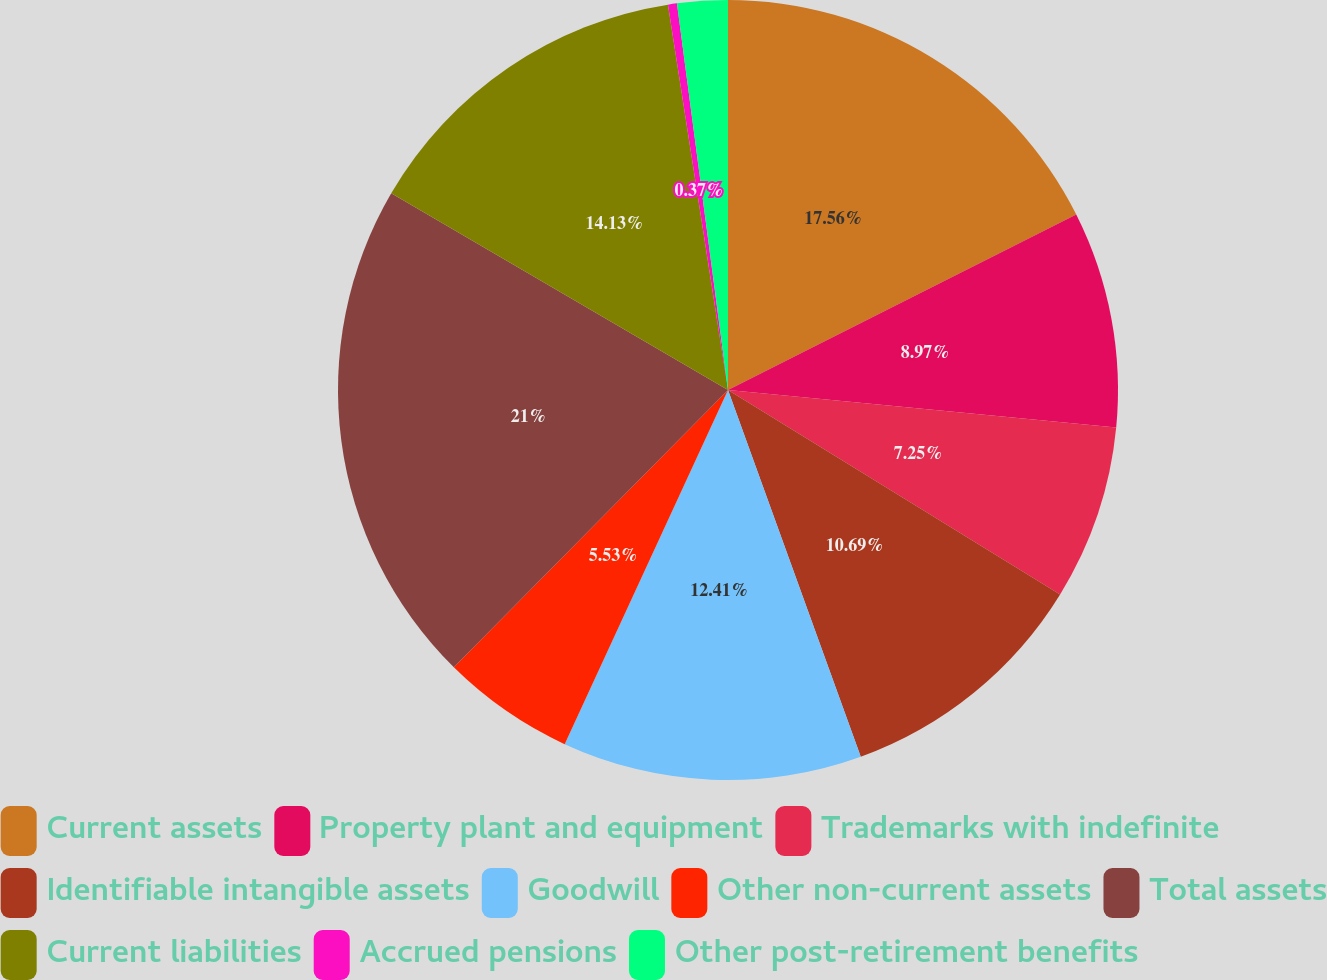<chart> <loc_0><loc_0><loc_500><loc_500><pie_chart><fcel>Current assets<fcel>Property plant and equipment<fcel>Trademarks with indefinite<fcel>Identifiable intangible assets<fcel>Goodwill<fcel>Other non-current assets<fcel>Total assets<fcel>Current liabilities<fcel>Accrued pensions<fcel>Other post-retirement benefits<nl><fcel>17.57%<fcel>8.97%<fcel>7.25%<fcel>10.69%<fcel>12.41%<fcel>5.53%<fcel>21.01%<fcel>14.13%<fcel>0.37%<fcel>2.09%<nl></chart> 